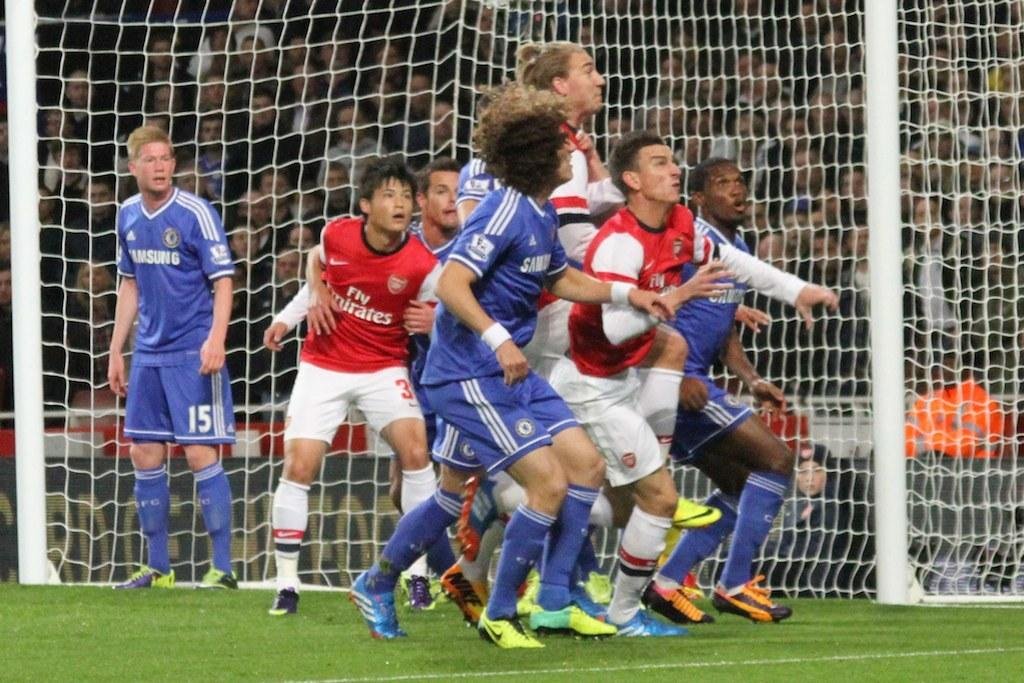<image>
Create a compact narrative representing the image presented. Players in Fly Emirates and Samsung uniforms all look up toward a soccer ball that's in the air. 